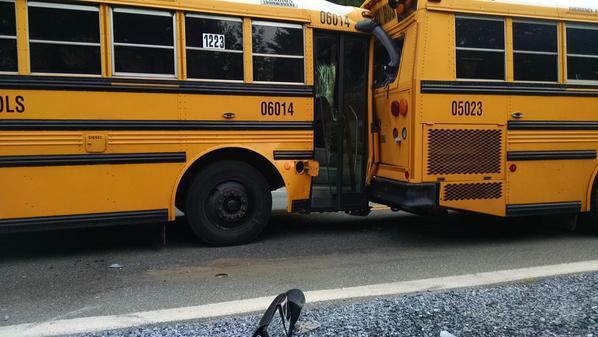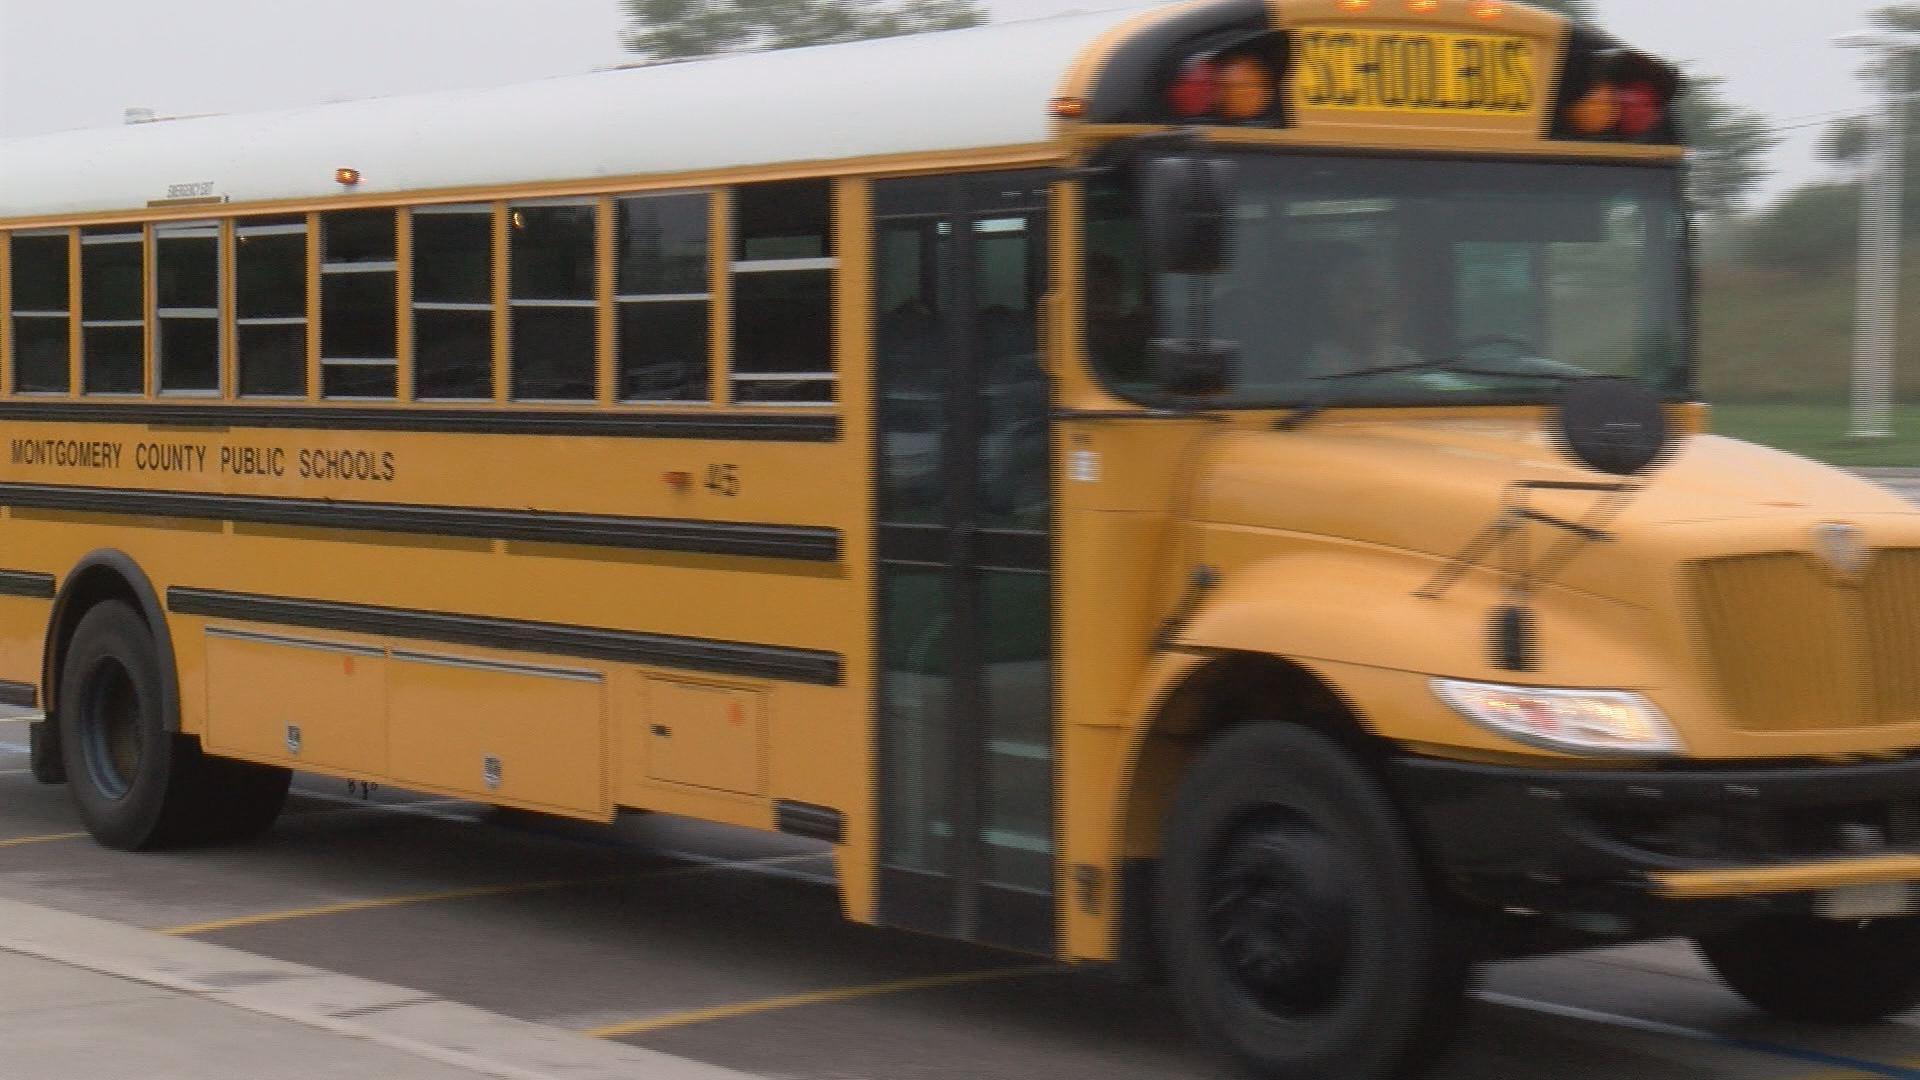The first image is the image on the left, the second image is the image on the right. Analyze the images presented: Is the assertion "There is no apparent damage to the bus in the image on the right." valid? Answer yes or no. Yes. The first image is the image on the left, the second image is the image on the right. Considering the images on both sides, is "The door of the bus in the image on the left has its door open." valid? Answer yes or no. Yes. 